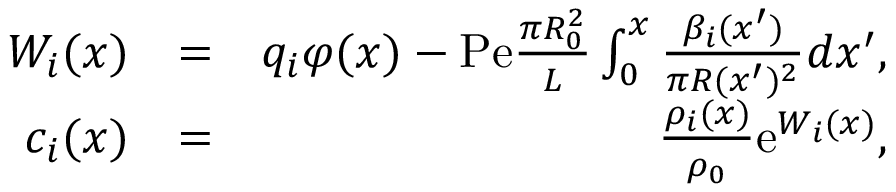<formula> <loc_0><loc_0><loc_500><loc_500>\begin{array} { r l r } { W _ { i } ( x ) } & { = } & { q _ { i } \varphi ( x ) - P e \frac { \pi R _ { 0 } ^ { 2 } } { L } \int _ { 0 } ^ { x } \frac { \beta _ { i } ( x ^ { \prime } ) } { \pi R ( x ^ { \prime } ) ^ { 2 } } d x ^ { \prime } , } \\ { c _ { i } ( x ) } & { = } & { \frac { \rho _ { i } ( x ) } { \rho _ { 0 } } e ^ { W _ { i } ( x ) } , } \end{array}</formula> 